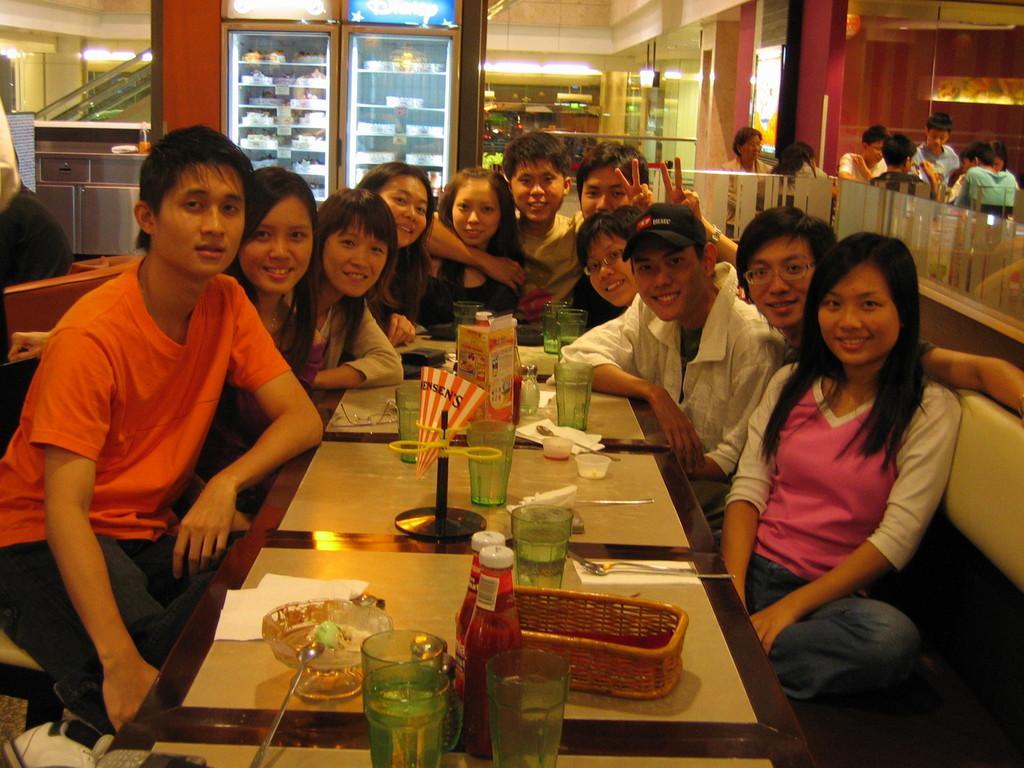Could you give a brief overview of what you see in this image? In this picture there are group of people sitting and smiling. There are glass, bowls, spoons, bottles, tissues and there is a box and basket on the table. At the back there are group of people sitting and there are refrigerators and there are objects. At the top there are lights. 